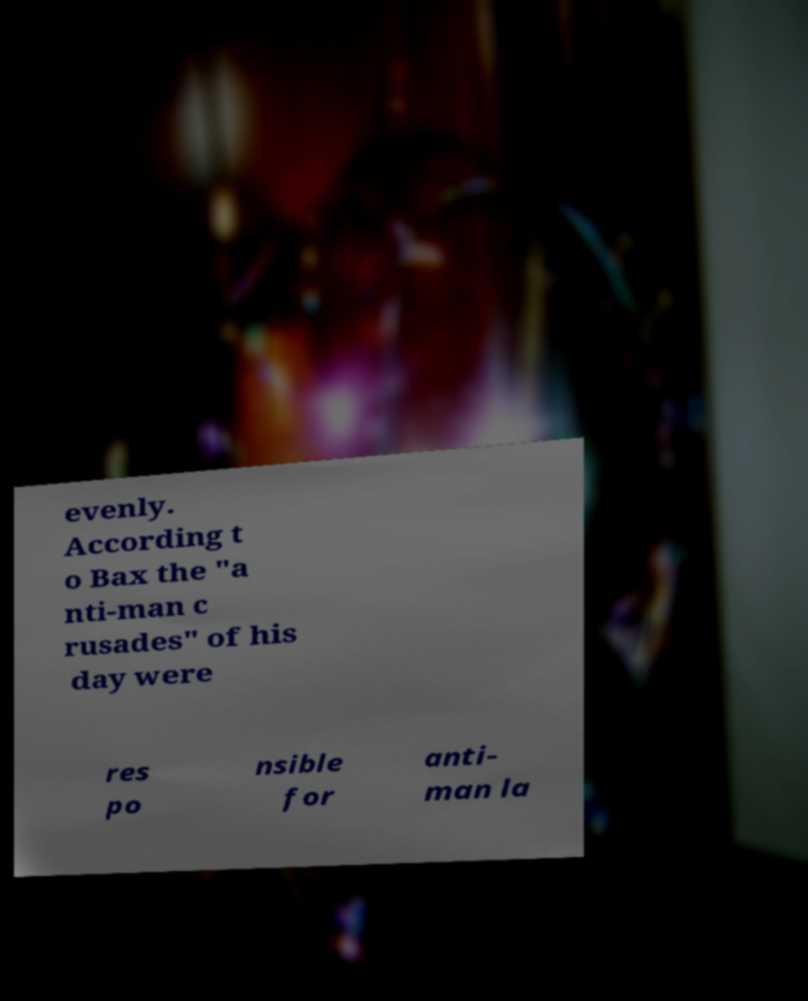Could you assist in decoding the text presented in this image and type it out clearly? evenly. According t o Bax the "a nti-man c rusades" of his day were res po nsible for anti- man la 